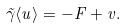Convert formula to latex. <formula><loc_0><loc_0><loc_500><loc_500>\tilde { \gamma } \langle u \rangle = - F + v .</formula> 